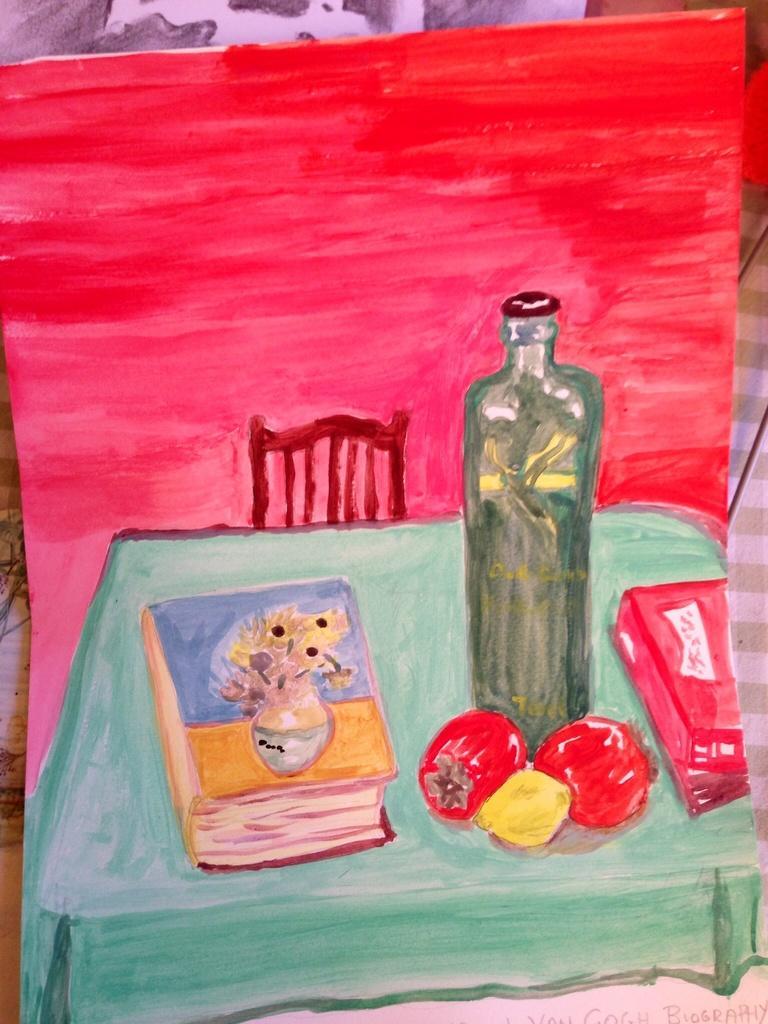Please provide a concise description of this image. In the image we can see a painting. In the painting, we can see chair, table and on the table there is a book, fruits, and a bottle. 